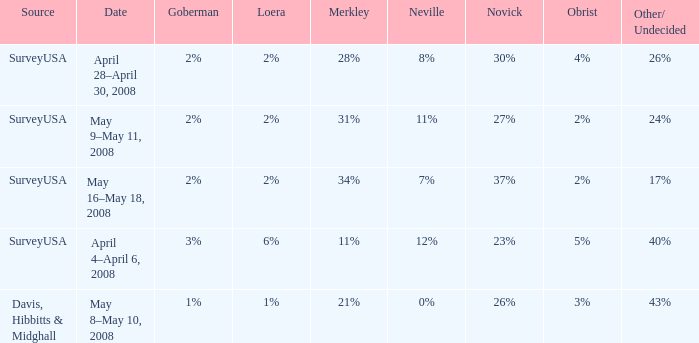Which Novick has a Source of surveyusa, and a Neville of 8%? 30%. 